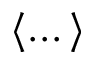Convert formula to latex. <formula><loc_0><loc_0><loc_500><loc_500>\langle \dots \rangle</formula> 